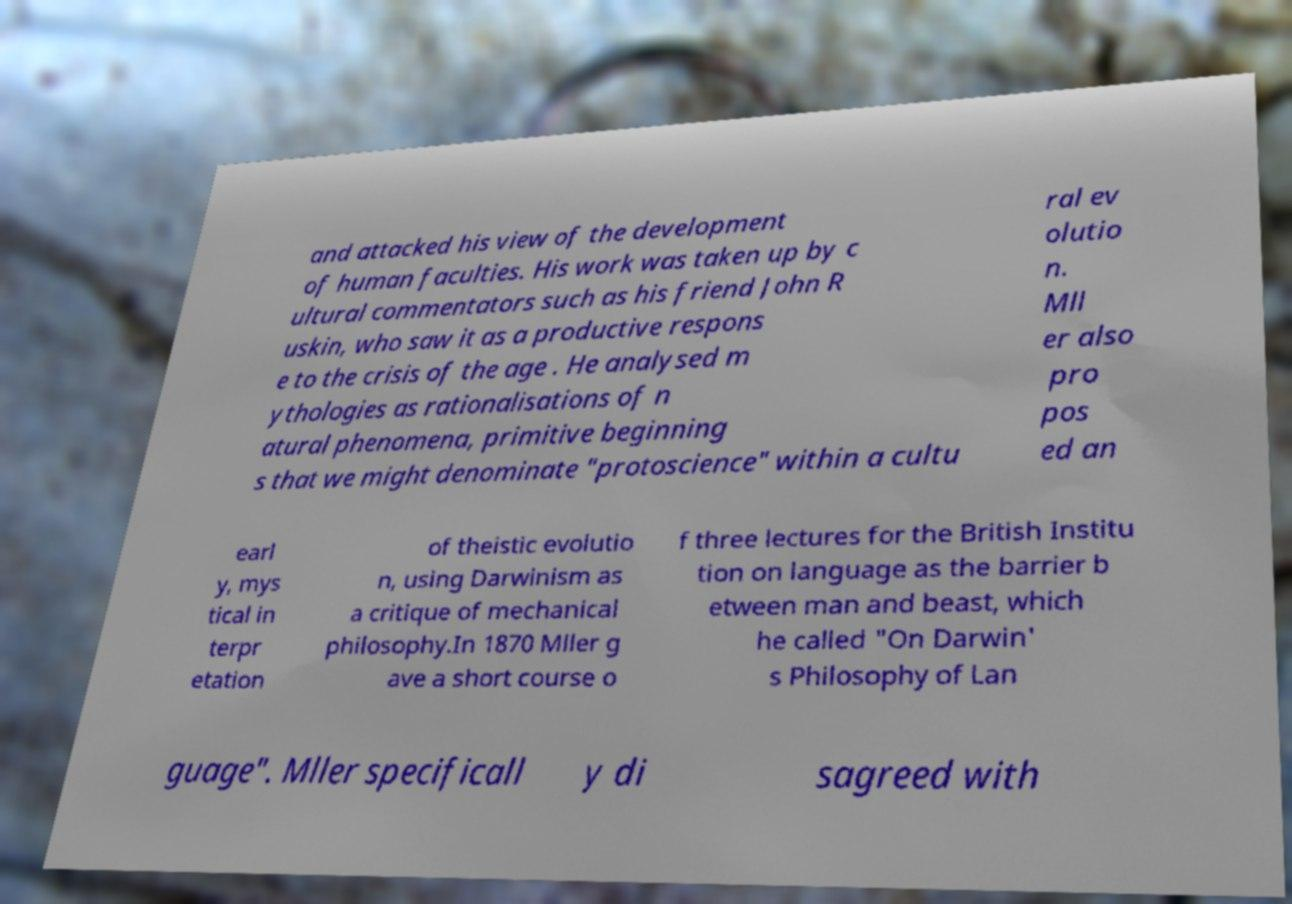For documentation purposes, I need the text within this image transcribed. Could you provide that? and attacked his view of the development of human faculties. His work was taken up by c ultural commentators such as his friend John R uskin, who saw it as a productive respons e to the crisis of the age . He analysed m ythologies as rationalisations of n atural phenomena, primitive beginning s that we might denominate "protoscience" within a cultu ral ev olutio n. Mll er also pro pos ed an earl y, mys tical in terpr etation of theistic evolutio n, using Darwinism as a critique of mechanical philosophy.In 1870 Mller g ave a short course o f three lectures for the British Institu tion on language as the barrier b etween man and beast, which he called "On Darwin' s Philosophy of Lan guage". Mller specificall y di sagreed with 